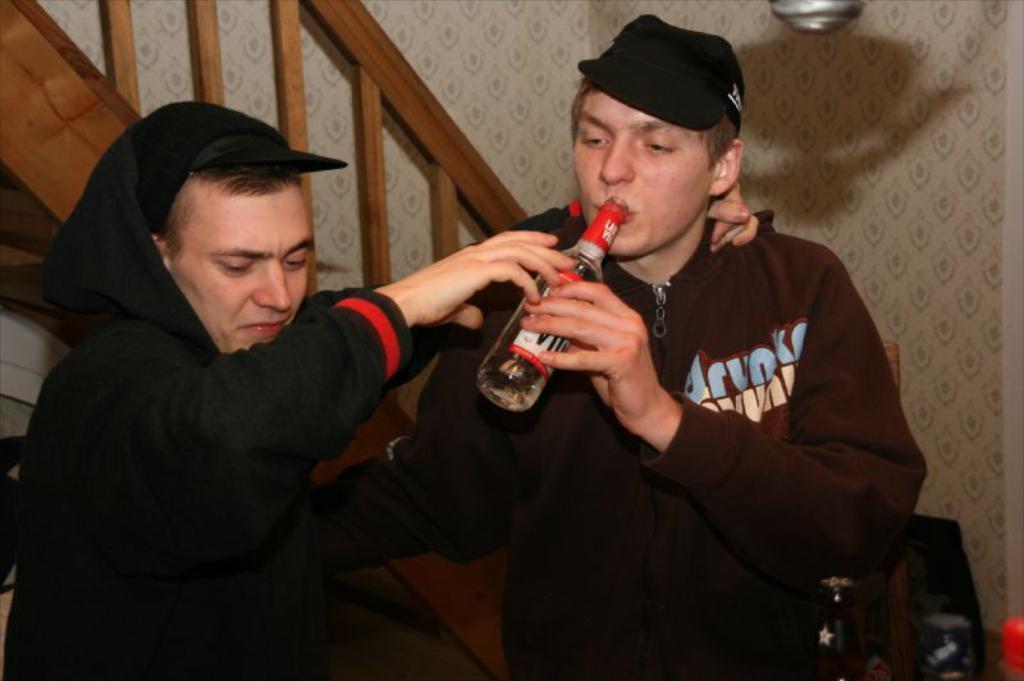Could you give a brief overview of what you see in this image? As we can see in the image, there are two persons standing. the person who is standing on the right side is wearing cap and holding bottle in his hand. Behind these two persons there is white color wall and stairs. 